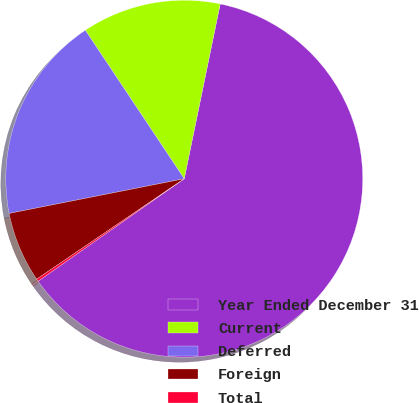Convert chart. <chart><loc_0><loc_0><loc_500><loc_500><pie_chart><fcel>Year Ended December 31<fcel>Current<fcel>Deferred<fcel>Foreign<fcel>Total<nl><fcel>62.04%<fcel>12.58%<fcel>18.76%<fcel>6.4%<fcel>0.22%<nl></chart> 